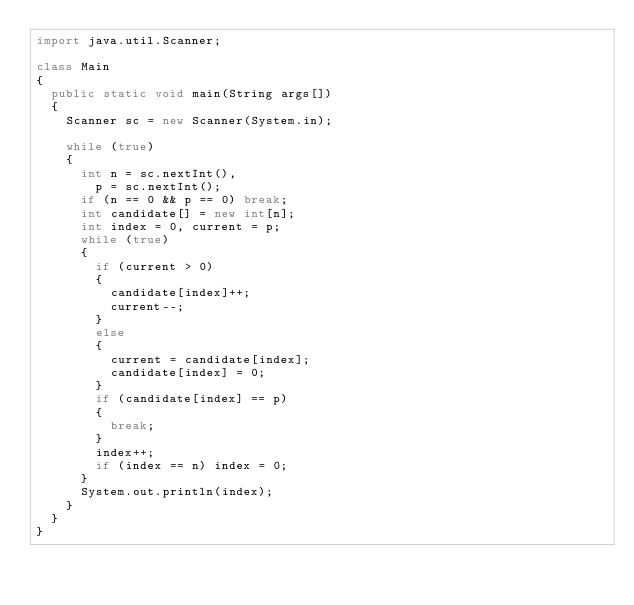Convert code to text. <code><loc_0><loc_0><loc_500><loc_500><_Java_>import java.util.Scanner;

class Main
{
	public static void main(String args[])
	{
		Scanner sc = new Scanner(System.in);
		
		while (true)
		{
			int n = sc.nextInt(),
				p = sc.nextInt();
			if (n == 0 && p == 0) break;
			int candidate[] = new int[n];
			int index = 0, current = p;
			while (true)
			{
				if (current > 0)
				{
					candidate[index]++;
					current--;
				}
				else
				{
					current = candidate[index];
					candidate[index] = 0;
				}
				if (candidate[index] == p)
				{
					break;
				}
				index++;
				if (index == n) index = 0;
			}
			System.out.println(index);
		}
	}
}</code> 